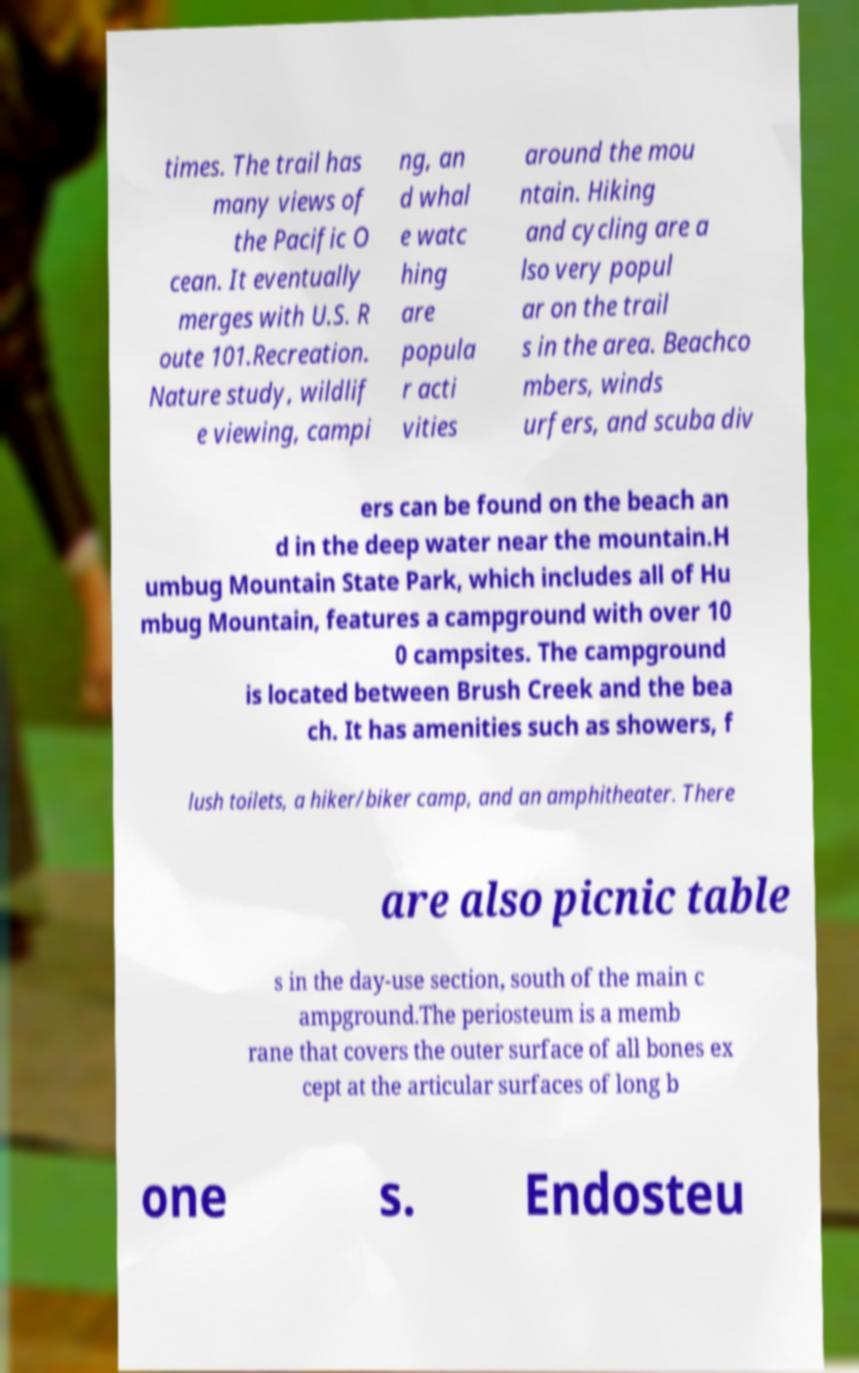Could you extract and type out the text from this image? times. The trail has many views of the Pacific O cean. It eventually merges with U.S. R oute 101.Recreation. Nature study, wildlif e viewing, campi ng, an d whal e watc hing are popula r acti vities around the mou ntain. Hiking and cycling are a lso very popul ar on the trail s in the area. Beachco mbers, winds urfers, and scuba div ers can be found on the beach an d in the deep water near the mountain.H umbug Mountain State Park, which includes all of Hu mbug Mountain, features a campground with over 10 0 campsites. The campground is located between Brush Creek and the bea ch. It has amenities such as showers, f lush toilets, a hiker/biker camp, and an amphitheater. There are also picnic table s in the day-use section, south of the main c ampground.The periosteum is a memb rane that covers the outer surface of all bones ex cept at the articular surfaces of long b one s. Endosteu 